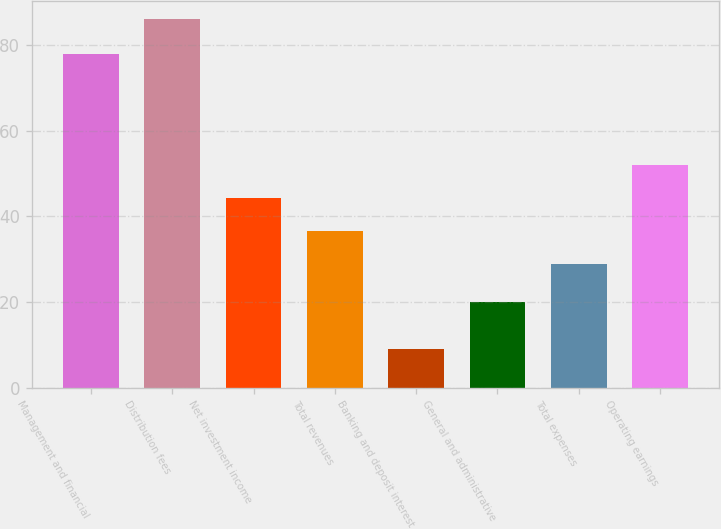<chart> <loc_0><loc_0><loc_500><loc_500><bar_chart><fcel>Management and financial<fcel>Distribution fees<fcel>Net investment income<fcel>Total revenues<fcel>Banking and deposit interest<fcel>General and administrative<fcel>Total expenses<fcel>Operating earnings<nl><fcel>78<fcel>86<fcel>44.4<fcel>36.7<fcel>9<fcel>20<fcel>29<fcel>52.1<nl></chart> 